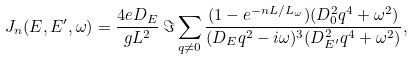<formula> <loc_0><loc_0><loc_500><loc_500>J _ { n } ( E , E ^ { \prime } , \omega ) = \frac { 4 e D _ { E } } { g L ^ { 2 } } \, \Im \sum _ { q \neq 0 } \frac { ( 1 - e ^ { - n L / L _ { \omega } } ) ( D _ { 0 } ^ { 2 } q ^ { 4 } + \omega ^ { 2 } ) } { ( D _ { E } q ^ { 2 } - i \omega ) ^ { 3 } ( D _ { E ^ { \prime } } ^ { 2 } q ^ { 4 } + \omega ^ { 2 } ) } ,</formula> 